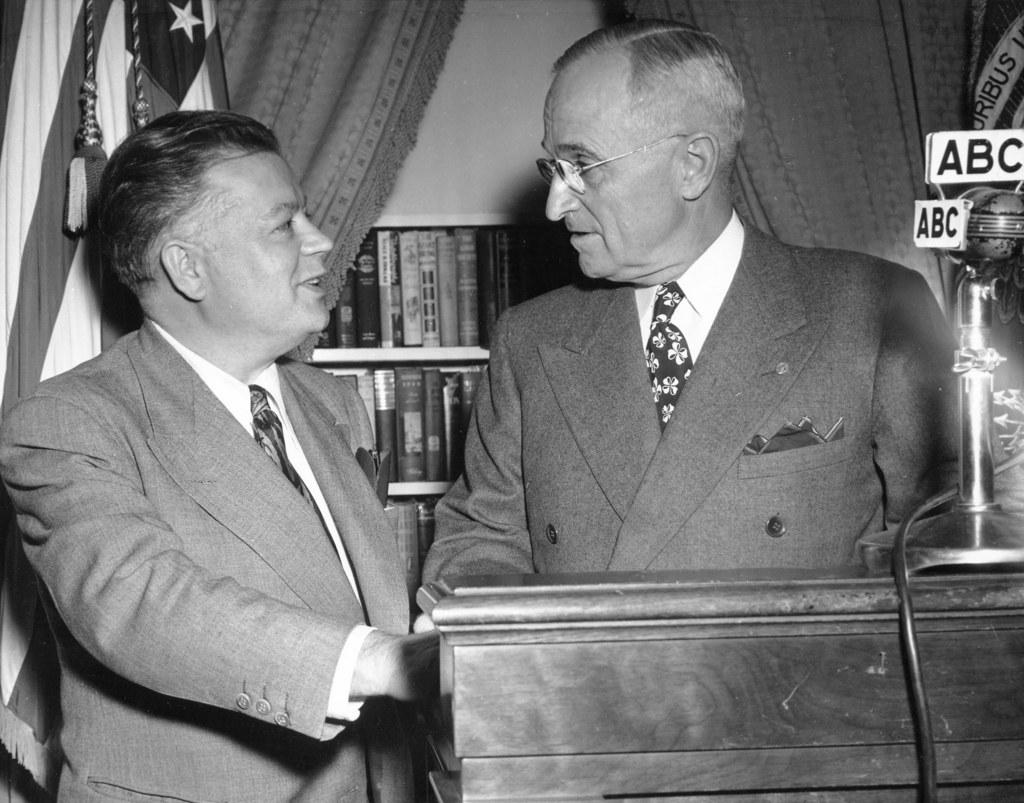<image>
Provide a brief description of the given image. Two men in a black and white picture with a microphone with ABC on it. 